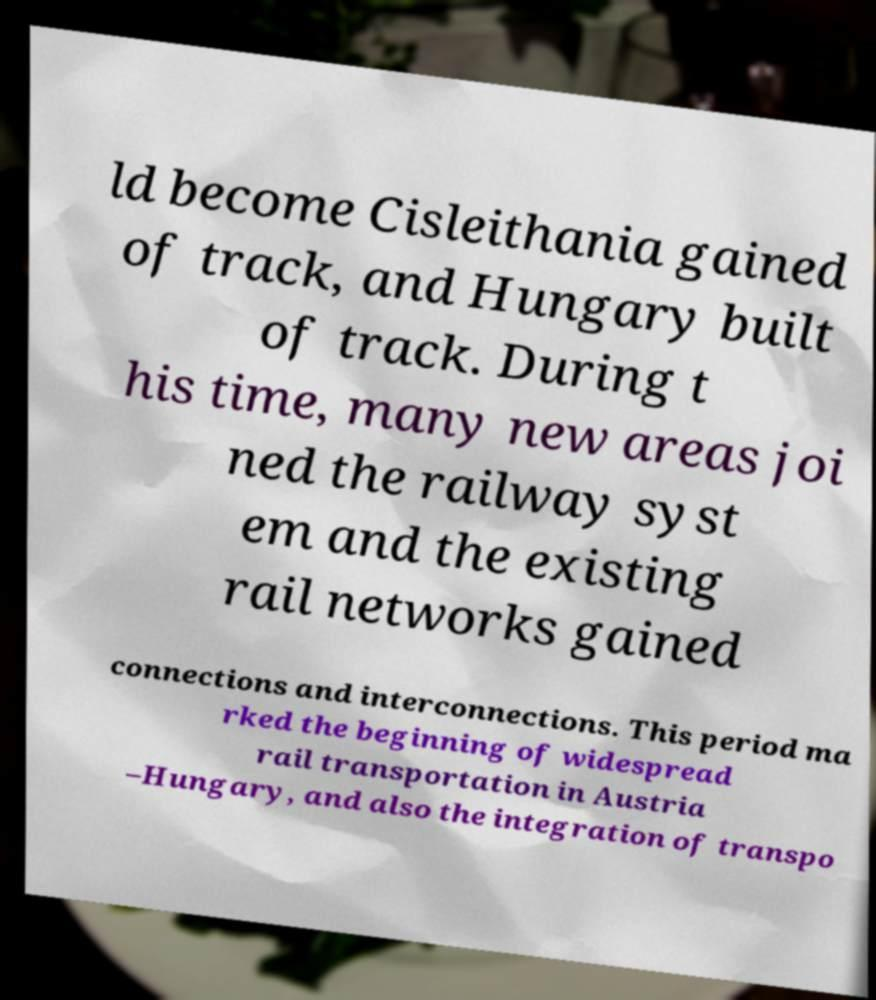Can you accurately transcribe the text from the provided image for me? ld become Cisleithania gained of track, and Hungary built of track. During t his time, many new areas joi ned the railway syst em and the existing rail networks gained connections and interconnections. This period ma rked the beginning of widespread rail transportation in Austria –Hungary, and also the integration of transpo 